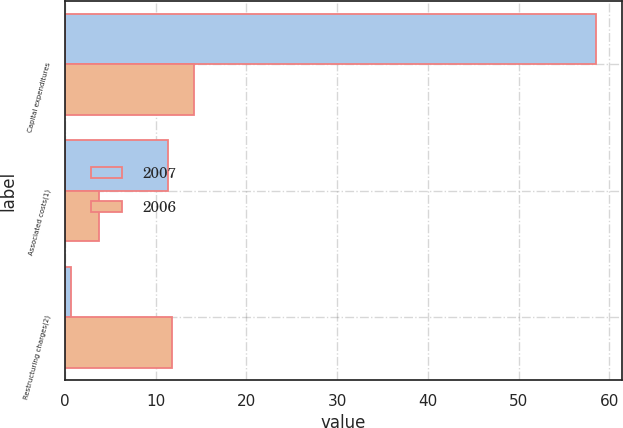Convert chart to OTSL. <chart><loc_0><loc_0><loc_500><loc_500><stacked_bar_chart><ecel><fcel>Capital expenditures<fcel>Associated costs(1)<fcel>Restructuring charges(2)<nl><fcel>2007<fcel>58.5<fcel>11.4<fcel>0.7<nl><fcel>2006<fcel>14.2<fcel>3.8<fcel>11.8<nl></chart> 